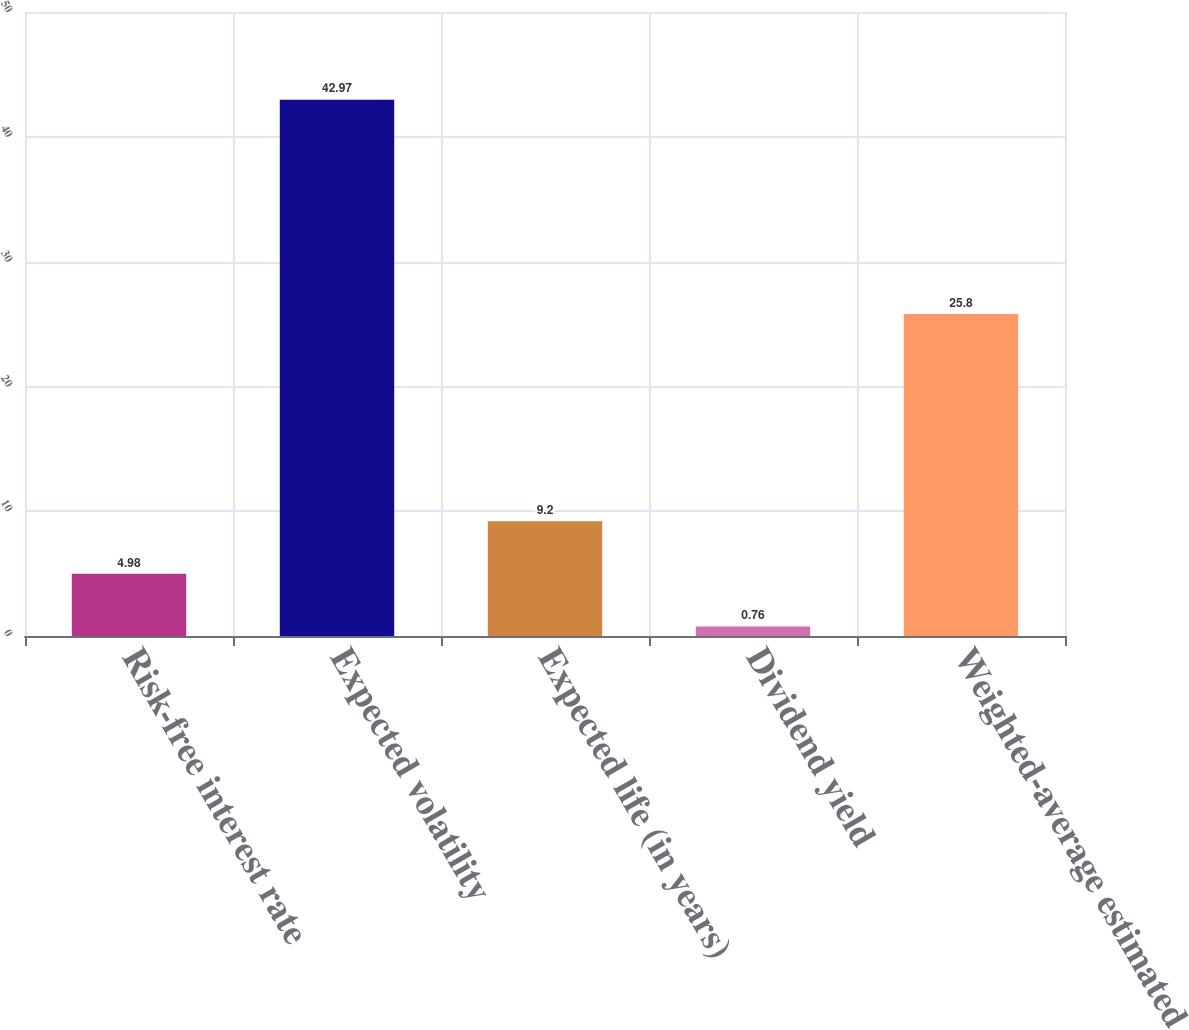Convert chart. <chart><loc_0><loc_0><loc_500><loc_500><bar_chart><fcel>Risk-free interest rate<fcel>Expected volatility<fcel>Expected life (in years)<fcel>Dividend yield<fcel>Weighted-average estimated<nl><fcel>4.98<fcel>42.97<fcel>9.2<fcel>0.76<fcel>25.8<nl></chart> 